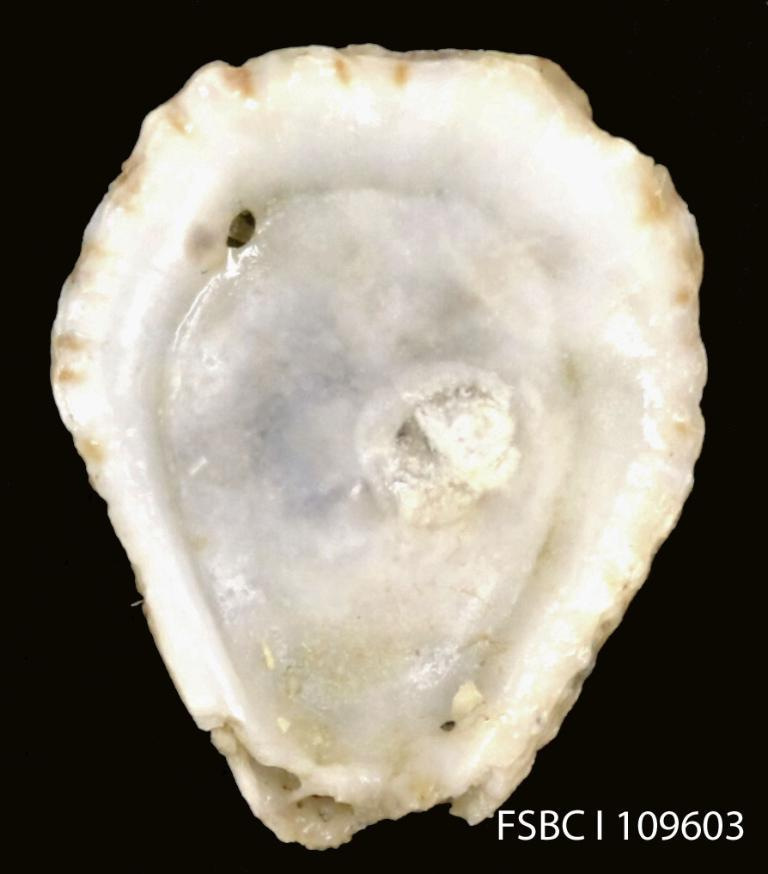What is the main subject of the image? There is an oyster in the middle of the image. What color is the background of the image? The background of the image is black. How many ladybugs can be seen crawling on the oyster in the image? There are no ladybugs present in the image; it only features an oyster. What type of coin is visible near the oyster in the image? There is no coin present in the image; it only features an oyster and a black background. 